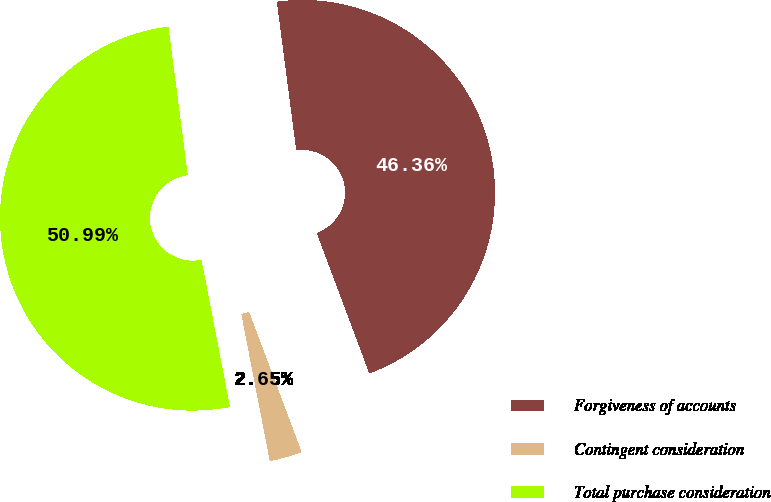<chart> <loc_0><loc_0><loc_500><loc_500><pie_chart><fcel>Forgiveness of accounts<fcel>Contingent consideration<fcel>Total purchase consideration<nl><fcel>46.36%<fcel>2.65%<fcel>50.99%<nl></chart> 